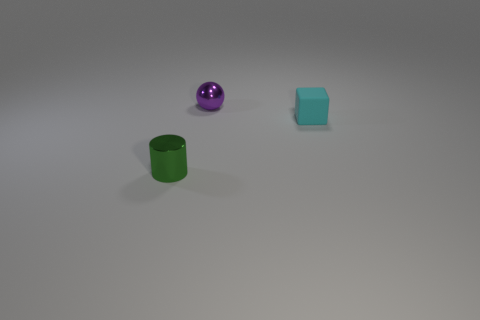What is the material of the green cylinder that is the same size as the rubber block?
Ensure brevity in your answer.  Metal. How many purple things are small objects or cylinders?
Keep it short and to the point. 1. There is a small thing that is in front of the purple object and on the left side of the rubber cube; what is its color?
Keep it short and to the point. Green. Is the material of the small object that is behind the tiny cyan cube the same as the small thing in front of the tiny matte object?
Your answer should be very brief. Yes. Are there more tiny things that are to the right of the cylinder than tiny shiny spheres in front of the rubber cube?
Offer a terse response. Yes. The green metal thing that is the same size as the purple metallic ball is what shape?
Offer a terse response. Cylinder. What number of things are tiny matte things or objects that are left of the cyan rubber block?
Offer a terse response. 3. There is a cyan block; what number of purple shiny spheres are behind it?
Your response must be concise. 1. The small object that is made of the same material as the ball is what color?
Your answer should be very brief. Green. What number of shiny things are either tiny things or tiny purple balls?
Offer a terse response. 2. 